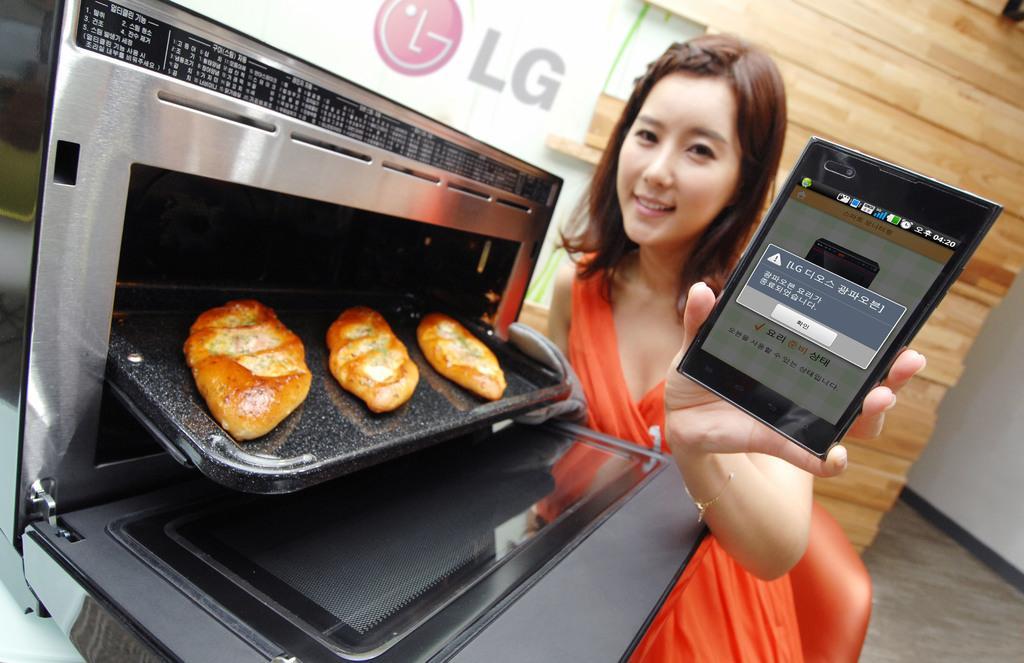Please provide a concise description of this image. This oven and this mobile are highlighted in this picture. This is a tray with food. This is an LG logo. This woman is holding this tray and mobile. 